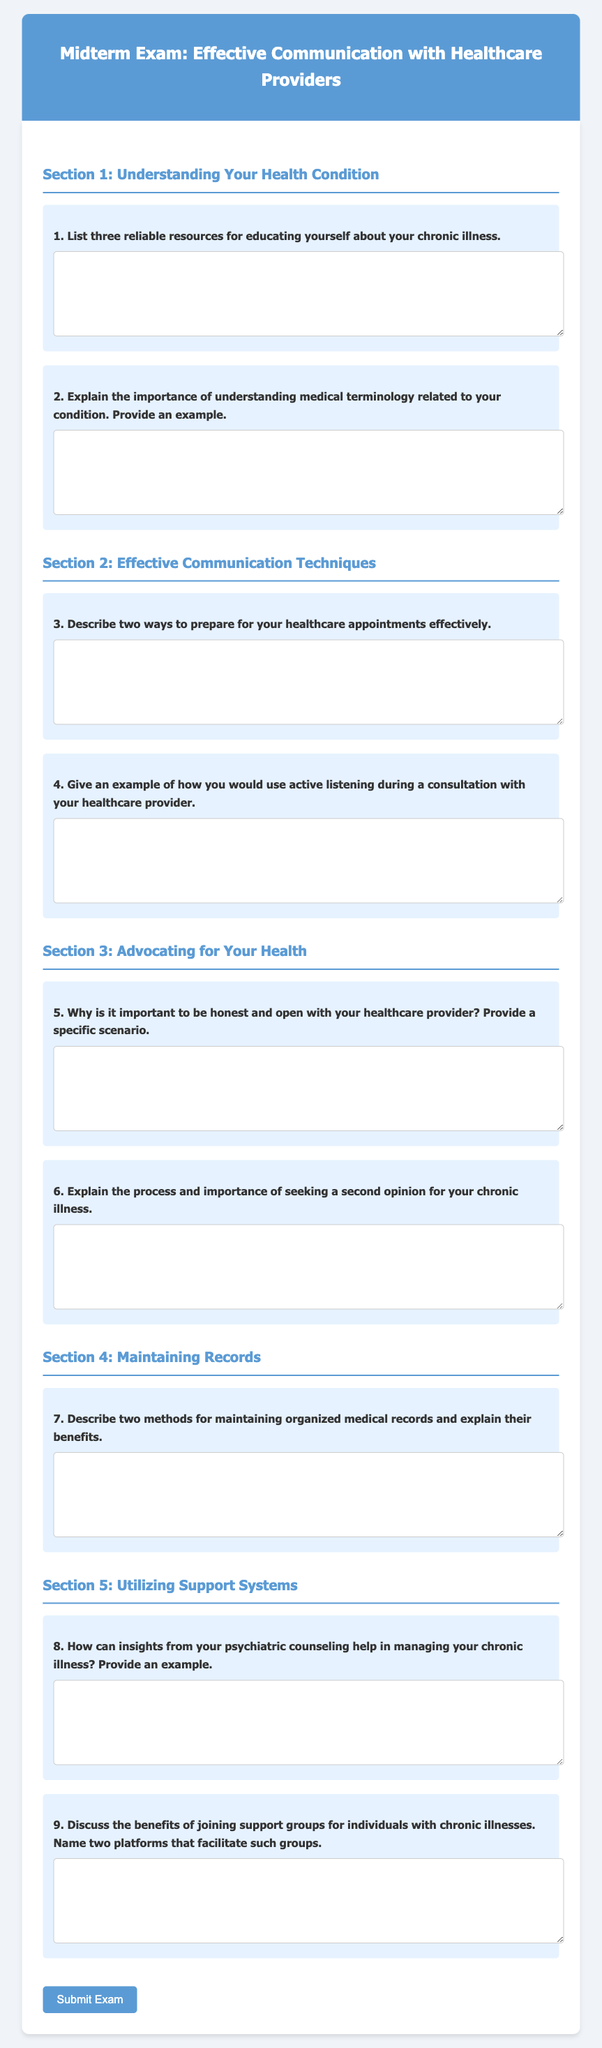What is the title of the document? The title of the document is provided in the header section, which displays the main focus of the midterm exam.
Answer: Midterm Exam: Effective Communication with Healthcare Providers How many sections are in the document? The document includes five distinct sections, each focusing on a different aspect of effective communication with healthcare providers.
Answer: 5 What is one method for maintaining organized medical records mentioned in the document? The document encourages a focus on methods for organizing records, which are described in detail under a specific question.
Answer: Two methods What is the purpose of utilizing psychiatric counseling in managing chronic illness? The document prompts an exploration of insights gained from counseling, reflecting its relevance to chronic illness management.
Answer: Managing chronic illness What is the number of questions in the Section 2: Effective Communication Techniques? Section 2 features a total of two questions directed towards effective communication techniques with healthcare providers.
Answer: 2 What is one benefit of joining support groups for individuals with chronic illnesses? The document emphasizes the advantages of support groups, which are elaborated upon in the respective section.
Answer: Benefits of joining support groups Why is it important to be honest and open with healthcare providers? The document outlines the significance of honesty in patient-provider communication, focusing on a specific scenario.
Answer: Importance of honesty What is the first question in Section 1: Understanding Your Health Condition? The document begins Section 1 with a focused inquiry related to reliable resources for health education.
Answer: List three reliable resources What type of questions are included in the document? The document comprises short-answer questions tailored to elicit responses about effective communication strategies and health management.
Answer: Short-answer questions 